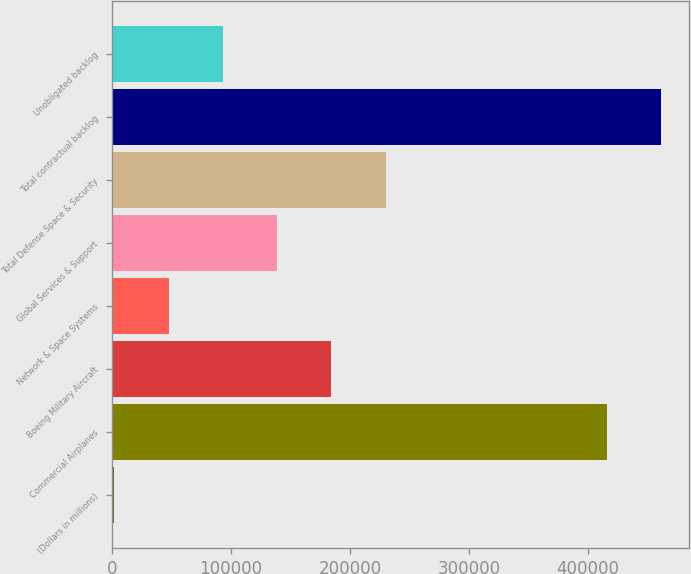Convert chart to OTSL. <chart><loc_0><loc_0><loc_500><loc_500><bar_chart><fcel>(Dollars in millions)<fcel>Commercial Airplanes<fcel>Boeing Military Aircraft<fcel>Network & Space Systems<fcel>Global Services & Support<fcel>Total Defense Space & Security<fcel>Total contractual backlog<fcel>Unobligated backlog<nl><fcel>2016<fcel>416198<fcel>184520<fcel>47642.1<fcel>138894<fcel>230146<fcel>461824<fcel>93268.2<nl></chart> 